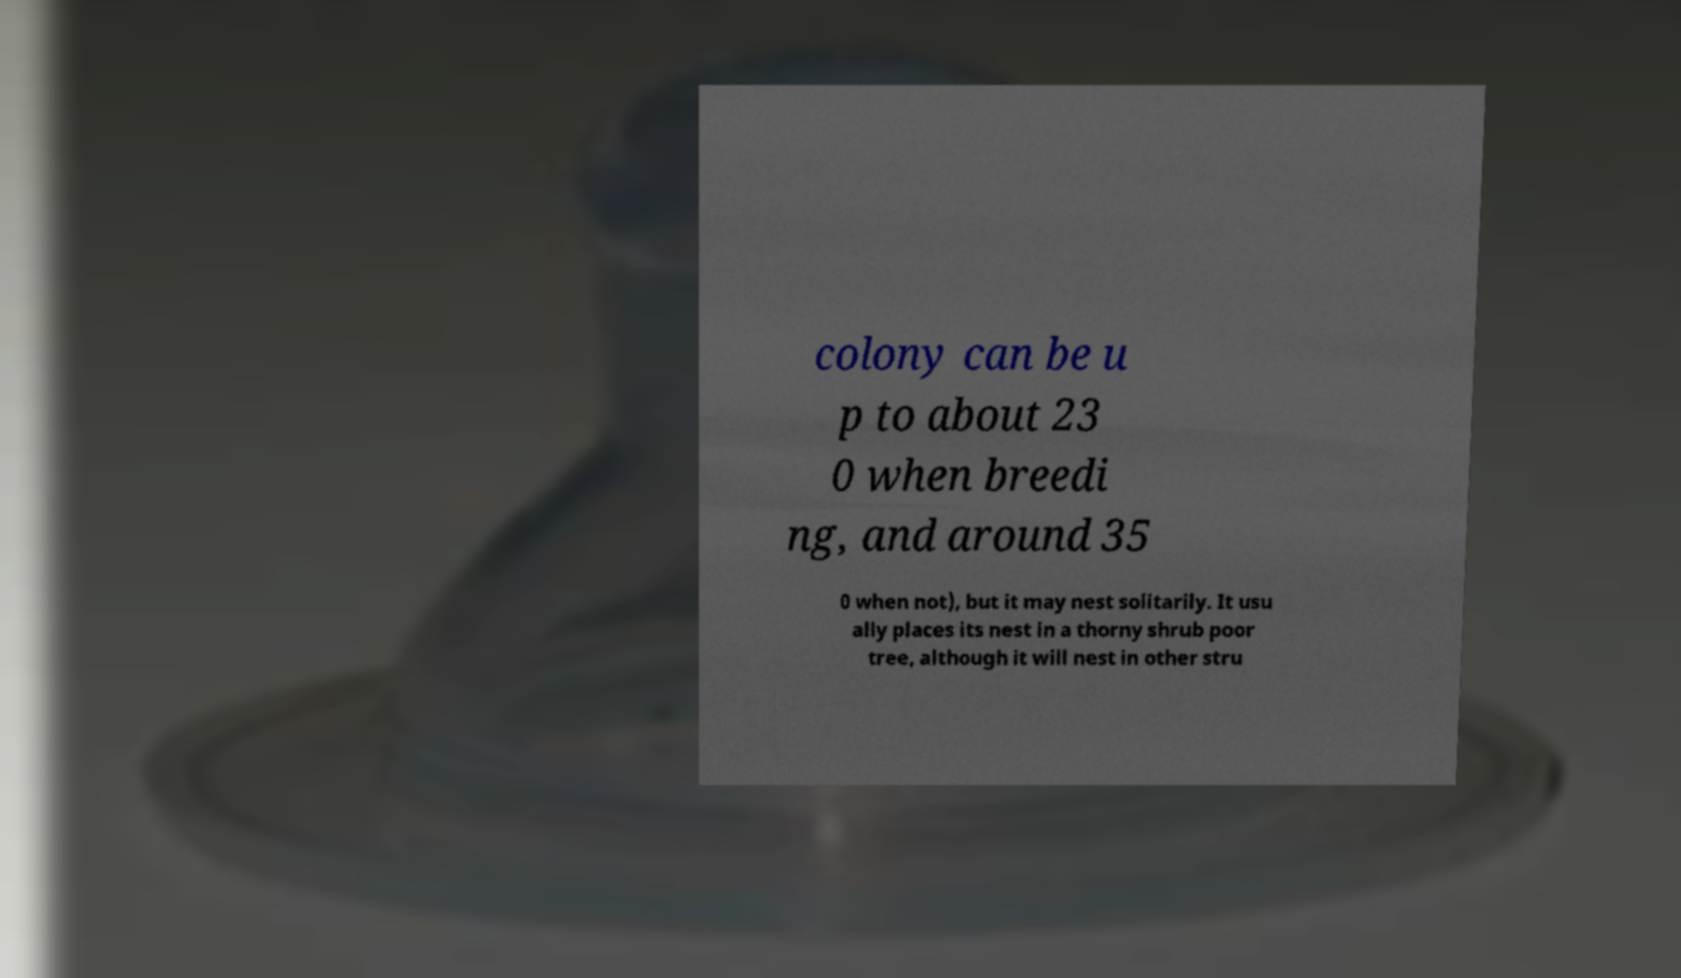Could you extract and type out the text from this image? colony can be u p to about 23 0 when breedi ng, and around 35 0 when not), but it may nest solitarily. It usu ally places its nest in a thorny shrub poor tree, although it will nest in other stru 